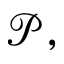<formula> <loc_0><loc_0><loc_500><loc_500>{ \mathcal { P } } ,</formula> 